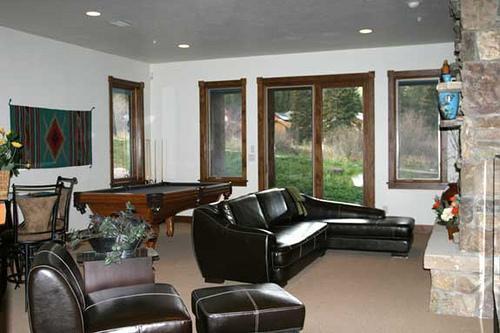How many couches can be seen?
Give a very brief answer. 2. How many chairs can you see?
Give a very brief answer. 2. How many potted plants are there?
Give a very brief answer. 1. How many umbrellas are open?
Give a very brief answer. 0. 